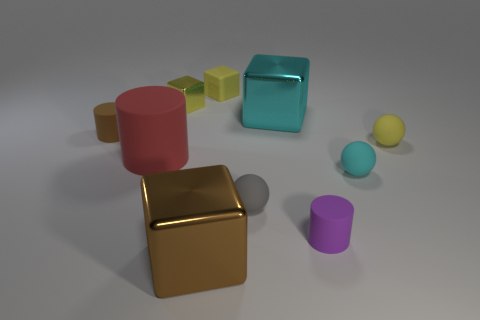There is a small matte sphere that is behind the large cylinder; is its color the same as the tiny metal block?
Your response must be concise. Yes. What number of balls are either tiny gray matte things or tiny cyan objects?
Offer a terse response. 2. How many small gray balls are in front of the metallic thing on the right side of the thing behind the yellow shiny thing?
Your answer should be compact. 1. There is a small ball that is the same color as the small rubber cube; what material is it?
Make the answer very short. Rubber. Are there more large shiny objects than small cyan shiny things?
Make the answer very short. Yes. Does the gray object have the same size as the purple matte thing?
Offer a terse response. Yes. How many things are purple rubber cylinders or large purple spheres?
Keep it short and to the point. 1. There is a large metallic thing that is behind the metallic cube that is in front of the cyan thing behind the red matte cylinder; what is its shape?
Offer a terse response. Cube. Do the small yellow object to the right of the tiny gray object and the large object in front of the tiny cyan object have the same material?
Offer a terse response. No. What is the material of the small cyan object that is the same shape as the gray rubber thing?
Your answer should be very brief. Rubber. 